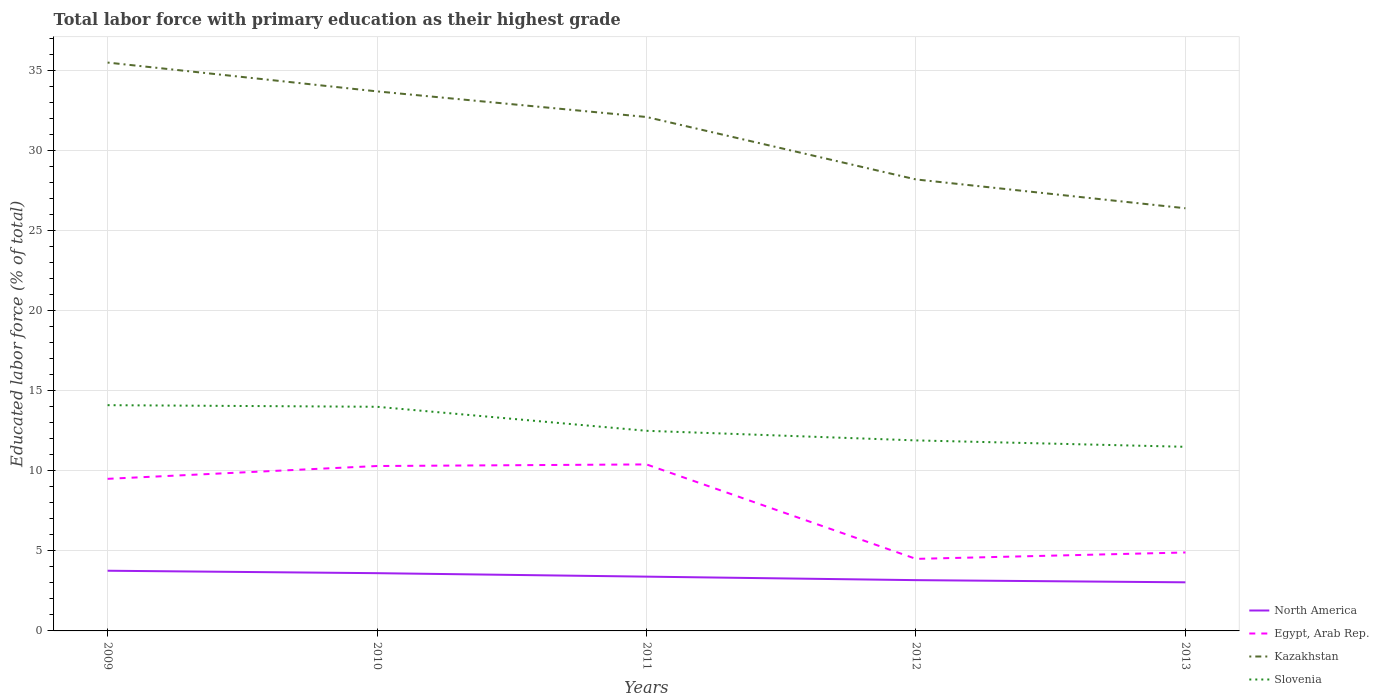How many different coloured lines are there?
Make the answer very short. 4. Does the line corresponding to North America intersect with the line corresponding to Slovenia?
Keep it short and to the point. No. Is the number of lines equal to the number of legend labels?
Keep it short and to the point. Yes. Across all years, what is the maximum percentage of total labor force with primary education in North America?
Your answer should be very brief. 3.04. In which year was the percentage of total labor force with primary education in North America maximum?
Give a very brief answer. 2013. What is the total percentage of total labor force with primary education in North America in the graph?
Offer a very short reply. 0.44. What is the difference between the highest and the second highest percentage of total labor force with primary education in Slovenia?
Provide a short and direct response. 2.6. What is the difference between the highest and the lowest percentage of total labor force with primary education in Slovenia?
Provide a succinct answer. 2. What is the difference between two consecutive major ticks on the Y-axis?
Ensure brevity in your answer.  5. Are the values on the major ticks of Y-axis written in scientific E-notation?
Keep it short and to the point. No. Does the graph contain any zero values?
Make the answer very short. No. Does the graph contain grids?
Your answer should be compact. Yes. What is the title of the graph?
Your answer should be very brief. Total labor force with primary education as their highest grade. Does "Bermuda" appear as one of the legend labels in the graph?
Your answer should be compact. No. What is the label or title of the X-axis?
Your response must be concise. Years. What is the label or title of the Y-axis?
Offer a terse response. Educated labor force (% of total). What is the Educated labor force (% of total) of North America in 2009?
Your answer should be very brief. 3.76. What is the Educated labor force (% of total) of Egypt, Arab Rep. in 2009?
Keep it short and to the point. 9.5. What is the Educated labor force (% of total) in Kazakhstan in 2009?
Ensure brevity in your answer.  35.5. What is the Educated labor force (% of total) in Slovenia in 2009?
Your answer should be compact. 14.1. What is the Educated labor force (% of total) of North America in 2010?
Make the answer very short. 3.61. What is the Educated labor force (% of total) in Egypt, Arab Rep. in 2010?
Keep it short and to the point. 10.3. What is the Educated labor force (% of total) of Kazakhstan in 2010?
Your response must be concise. 33.7. What is the Educated labor force (% of total) of North America in 2011?
Offer a terse response. 3.39. What is the Educated labor force (% of total) in Egypt, Arab Rep. in 2011?
Provide a succinct answer. 10.4. What is the Educated labor force (% of total) of Kazakhstan in 2011?
Offer a terse response. 32.1. What is the Educated labor force (% of total) in Slovenia in 2011?
Keep it short and to the point. 12.5. What is the Educated labor force (% of total) in North America in 2012?
Your answer should be very brief. 3.17. What is the Educated labor force (% of total) of Kazakhstan in 2012?
Provide a short and direct response. 28.2. What is the Educated labor force (% of total) of Slovenia in 2012?
Your answer should be compact. 11.9. What is the Educated labor force (% of total) in North America in 2013?
Offer a terse response. 3.04. What is the Educated labor force (% of total) of Egypt, Arab Rep. in 2013?
Your response must be concise. 4.9. What is the Educated labor force (% of total) in Kazakhstan in 2013?
Give a very brief answer. 26.4. What is the Educated labor force (% of total) of Slovenia in 2013?
Make the answer very short. 11.5. Across all years, what is the maximum Educated labor force (% of total) of North America?
Make the answer very short. 3.76. Across all years, what is the maximum Educated labor force (% of total) of Egypt, Arab Rep.?
Offer a very short reply. 10.4. Across all years, what is the maximum Educated labor force (% of total) of Kazakhstan?
Your response must be concise. 35.5. Across all years, what is the maximum Educated labor force (% of total) in Slovenia?
Your answer should be compact. 14.1. Across all years, what is the minimum Educated labor force (% of total) of North America?
Provide a short and direct response. 3.04. Across all years, what is the minimum Educated labor force (% of total) in Egypt, Arab Rep.?
Offer a terse response. 4.5. Across all years, what is the minimum Educated labor force (% of total) of Kazakhstan?
Offer a very short reply. 26.4. Across all years, what is the minimum Educated labor force (% of total) of Slovenia?
Your response must be concise. 11.5. What is the total Educated labor force (% of total) of North America in the graph?
Ensure brevity in your answer.  16.97. What is the total Educated labor force (% of total) in Egypt, Arab Rep. in the graph?
Ensure brevity in your answer.  39.6. What is the total Educated labor force (% of total) in Kazakhstan in the graph?
Your answer should be compact. 155.9. What is the difference between the Educated labor force (% of total) of North America in 2009 and that in 2010?
Make the answer very short. 0.15. What is the difference between the Educated labor force (% of total) in Kazakhstan in 2009 and that in 2010?
Provide a succinct answer. 1.8. What is the difference between the Educated labor force (% of total) in Slovenia in 2009 and that in 2010?
Offer a terse response. 0.1. What is the difference between the Educated labor force (% of total) in North America in 2009 and that in 2011?
Your response must be concise. 0.37. What is the difference between the Educated labor force (% of total) in Egypt, Arab Rep. in 2009 and that in 2011?
Offer a terse response. -0.9. What is the difference between the Educated labor force (% of total) of Slovenia in 2009 and that in 2011?
Provide a short and direct response. 1.6. What is the difference between the Educated labor force (% of total) of North America in 2009 and that in 2012?
Make the answer very short. 0.59. What is the difference between the Educated labor force (% of total) of North America in 2009 and that in 2013?
Your response must be concise. 0.72. What is the difference between the Educated labor force (% of total) of North America in 2010 and that in 2011?
Offer a terse response. 0.22. What is the difference between the Educated labor force (% of total) in Kazakhstan in 2010 and that in 2011?
Offer a terse response. 1.6. What is the difference between the Educated labor force (% of total) of North America in 2010 and that in 2012?
Your response must be concise. 0.44. What is the difference between the Educated labor force (% of total) of Egypt, Arab Rep. in 2010 and that in 2012?
Your response must be concise. 5.8. What is the difference between the Educated labor force (% of total) in Slovenia in 2010 and that in 2013?
Keep it short and to the point. 2.5. What is the difference between the Educated labor force (% of total) of North America in 2011 and that in 2012?
Ensure brevity in your answer.  0.22. What is the difference between the Educated labor force (% of total) of Egypt, Arab Rep. in 2011 and that in 2012?
Your answer should be compact. 5.9. What is the difference between the Educated labor force (% of total) of Slovenia in 2011 and that in 2012?
Provide a succinct answer. 0.6. What is the difference between the Educated labor force (% of total) of North America in 2011 and that in 2013?
Keep it short and to the point. 0.35. What is the difference between the Educated labor force (% of total) of Egypt, Arab Rep. in 2011 and that in 2013?
Your answer should be compact. 5.5. What is the difference between the Educated labor force (% of total) of Slovenia in 2011 and that in 2013?
Your answer should be compact. 1. What is the difference between the Educated labor force (% of total) in North America in 2012 and that in 2013?
Offer a very short reply. 0.14. What is the difference between the Educated labor force (% of total) in North America in 2009 and the Educated labor force (% of total) in Egypt, Arab Rep. in 2010?
Your answer should be compact. -6.54. What is the difference between the Educated labor force (% of total) in North America in 2009 and the Educated labor force (% of total) in Kazakhstan in 2010?
Ensure brevity in your answer.  -29.94. What is the difference between the Educated labor force (% of total) in North America in 2009 and the Educated labor force (% of total) in Slovenia in 2010?
Keep it short and to the point. -10.24. What is the difference between the Educated labor force (% of total) in Egypt, Arab Rep. in 2009 and the Educated labor force (% of total) in Kazakhstan in 2010?
Make the answer very short. -24.2. What is the difference between the Educated labor force (% of total) in Egypt, Arab Rep. in 2009 and the Educated labor force (% of total) in Slovenia in 2010?
Your answer should be very brief. -4.5. What is the difference between the Educated labor force (% of total) in North America in 2009 and the Educated labor force (% of total) in Egypt, Arab Rep. in 2011?
Offer a very short reply. -6.64. What is the difference between the Educated labor force (% of total) of North America in 2009 and the Educated labor force (% of total) of Kazakhstan in 2011?
Your answer should be very brief. -28.34. What is the difference between the Educated labor force (% of total) in North America in 2009 and the Educated labor force (% of total) in Slovenia in 2011?
Ensure brevity in your answer.  -8.74. What is the difference between the Educated labor force (% of total) of Egypt, Arab Rep. in 2009 and the Educated labor force (% of total) of Kazakhstan in 2011?
Your answer should be very brief. -22.6. What is the difference between the Educated labor force (% of total) in Kazakhstan in 2009 and the Educated labor force (% of total) in Slovenia in 2011?
Offer a terse response. 23. What is the difference between the Educated labor force (% of total) of North America in 2009 and the Educated labor force (% of total) of Egypt, Arab Rep. in 2012?
Your response must be concise. -0.74. What is the difference between the Educated labor force (% of total) of North America in 2009 and the Educated labor force (% of total) of Kazakhstan in 2012?
Offer a terse response. -24.44. What is the difference between the Educated labor force (% of total) of North America in 2009 and the Educated labor force (% of total) of Slovenia in 2012?
Give a very brief answer. -8.14. What is the difference between the Educated labor force (% of total) of Egypt, Arab Rep. in 2009 and the Educated labor force (% of total) of Kazakhstan in 2012?
Your answer should be very brief. -18.7. What is the difference between the Educated labor force (% of total) of Kazakhstan in 2009 and the Educated labor force (% of total) of Slovenia in 2012?
Make the answer very short. 23.6. What is the difference between the Educated labor force (% of total) of North America in 2009 and the Educated labor force (% of total) of Egypt, Arab Rep. in 2013?
Provide a short and direct response. -1.14. What is the difference between the Educated labor force (% of total) in North America in 2009 and the Educated labor force (% of total) in Kazakhstan in 2013?
Your response must be concise. -22.64. What is the difference between the Educated labor force (% of total) in North America in 2009 and the Educated labor force (% of total) in Slovenia in 2013?
Provide a short and direct response. -7.74. What is the difference between the Educated labor force (% of total) of Egypt, Arab Rep. in 2009 and the Educated labor force (% of total) of Kazakhstan in 2013?
Your answer should be very brief. -16.9. What is the difference between the Educated labor force (% of total) in Egypt, Arab Rep. in 2009 and the Educated labor force (% of total) in Slovenia in 2013?
Ensure brevity in your answer.  -2. What is the difference between the Educated labor force (% of total) in Kazakhstan in 2009 and the Educated labor force (% of total) in Slovenia in 2013?
Offer a terse response. 24. What is the difference between the Educated labor force (% of total) in North America in 2010 and the Educated labor force (% of total) in Egypt, Arab Rep. in 2011?
Keep it short and to the point. -6.79. What is the difference between the Educated labor force (% of total) in North America in 2010 and the Educated labor force (% of total) in Kazakhstan in 2011?
Give a very brief answer. -28.49. What is the difference between the Educated labor force (% of total) of North America in 2010 and the Educated labor force (% of total) of Slovenia in 2011?
Make the answer very short. -8.89. What is the difference between the Educated labor force (% of total) of Egypt, Arab Rep. in 2010 and the Educated labor force (% of total) of Kazakhstan in 2011?
Keep it short and to the point. -21.8. What is the difference between the Educated labor force (% of total) of Kazakhstan in 2010 and the Educated labor force (% of total) of Slovenia in 2011?
Ensure brevity in your answer.  21.2. What is the difference between the Educated labor force (% of total) of North America in 2010 and the Educated labor force (% of total) of Egypt, Arab Rep. in 2012?
Give a very brief answer. -0.89. What is the difference between the Educated labor force (% of total) of North America in 2010 and the Educated labor force (% of total) of Kazakhstan in 2012?
Your response must be concise. -24.59. What is the difference between the Educated labor force (% of total) in North America in 2010 and the Educated labor force (% of total) in Slovenia in 2012?
Your response must be concise. -8.29. What is the difference between the Educated labor force (% of total) of Egypt, Arab Rep. in 2010 and the Educated labor force (% of total) of Kazakhstan in 2012?
Offer a terse response. -17.9. What is the difference between the Educated labor force (% of total) in Egypt, Arab Rep. in 2010 and the Educated labor force (% of total) in Slovenia in 2012?
Provide a succinct answer. -1.6. What is the difference between the Educated labor force (% of total) in Kazakhstan in 2010 and the Educated labor force (% of total) in Slovenia in 2012?
Offer a terse response. 21.8. What is the difference between the Educated labor force (% of total) of North America in 2010 and the Educated labor force (% of total) of Egypt, Arab Rep. in 2013?
Make the answer very short. -1.29. What is the difference between the Educated labor force (% of total) in North America in 2010 and the Educated labor force (% of total) in Kazakhstan in 2013?
Your answer should be very brief. -22.79. What is the difference between the Educated labor force (% of total) in North America in 2010 and the Educated labor force (% of total) in Slovenia in 2013?
Your answer should be very brief. -7.89. What is the difference between the Educated labor force (% of total) in Egypt, Arab Rep. in 2010 and the Educated labor force (% of total) in Kazakhstan in 2013?
Provide a short and direct response. -16.1. What is the difference between the Educated labor force (% of total) of Egypt, Arab Rep. in 2010 and the Educated labor force (% of total) of Slovenia in 2013?
Make the answer very short. -1.2. What is the difference between the Educated labor force (% of total) of Kazakhstan in 2010 and the Educated labor force (% of total) of Slovenia in 2013?
Make the answer very short. 22.2. What is the difference between the Educated labor force (% of total) in North America in 2011 and the Educated labor force (% of total) in Egypt, Arab Rep. in 2012?
Offer a very short reply. -1.11. What is the difference between the Educated labor force (% of total) of North America in 2011 and the Educated labor force (% of total) of Kazakhstan in 2012?
Offer a very short reply. -24.81. What is the difference between the Educated labor force (% of total) of North America in 2011 and the Educated labor force (% of total) of Slovenia in 2012?
Your answer should be compact. -8.51. What is the difference between the Educated labor force (% of total) in Egypt, Arab Rep. in 2011 and the Educated labor force (% of total) in Kazakhstan in 2012?
Offer a very short reply. -17.8. What is the difference between the Educated labor force (% of total) in Kazakhstan in 2011 and the Educated labor force (% of total) in Slovenia in 2012?
Keep it short and to the point. 20.2. What is the difference between the Educated labor force (% of total) of North America in 2011 and the Educated labor force (% of total) of Egypt, Arab Rep. in 2013?
Make the answer very short. -1.51. What is the difference between the Educated labor force (% of total) in North America in 2011 and the Educated labor force (% of total) in Kazakhstan in 2013?
Offer a terse response. -23.01. What is the difference between the Educated labor force (% of total) in North America in 2011 and the Educated labor force (% of total) in Slovenia in 2013?
Your answer should be compact. -8.11. What is the difference between the Educated labor force (% of total) in Egypt, Arab Rep. in 2011 and the Educated labor force (% of total) in Kazakhstan in 2013?
Your answer should be very brief. -16. What is the difference between the Educated labor force (% of total) in Egypt, Arab Rep. in 2011 and the Educated labor force (% of total) in Slovenia in 2013?
Give a very brief answer. -1.1. What is the difference between the Educated labor force (% of total) in Kazakhstan in 2011 and the Educated labor force (% of total) in Slovenia in 2013?
Make the answer very short. 20.6. What is the difference between the Educated labor force (% of total) in North America in 2012 and the Educated labor force (% of total) in Egypt, Arab Rep. in 2013?
Provide a succinct answer. -1.73. What is the difference between the Educated labor force (% of total) in North America in 2012 and the Educated labor force (% of total) in Kazakhstan in 2013?
Give a very brief answer. -23.23. What is the difference between the Educated labor force (% of total) of North America in 2012 and the Educated labor force (% of total) of Slovenia in 2013?
Offer a terse response. -8.33. What is the difference between the Educated labor force (% of total) in Egypt, Arab Rep. in 2012 and the Educated labor force (% of total) in Kazakhstan in 2013?
Your answer should be compact. -21.9. What is the difference between the Educated labor force (% of total) of Egypt, Arab Rep. in 2012 and the Educated labor force (% of total) of Slovenia in 2013?
Offer a terse response. -7. What is the difference between the Educated labor force (% of total) of Kazakhstan in 2012 and the Educated labor force (% of total) of Slovenia in 2013?
Provide a succinct answer. 16.7. What is the average Educated labor force (% of total) of North America per year?
Provide a succinct answer. 3.39. What is the average Educated labor force (% of total) of Egypt, Arab Rep. per year?
Offer a very short reply. 7.92. What is the average Educated labor force (% of total) of Kazakhstan per year?
Offer a very short reply. 31.18. What is the average Educated labor force (% of total) in Slovenia per year?
Your answer should be compact. 12.8. In the year 2009, what is the difference between the Educated labor force (% of total) in North America and Educated labor force (% of total) in Egypt, Arab Rep.?
Ensure brevity in your answer.  -5.74. In the year 2009, what is the difference between the Educated labor force (% of total) of North America and Educated labor force (% of total) of Kazakhstan?
Offer a very short reply. -31.74. In the year 2009, what is the difference between the Educated labor force (% of total) in North America and Educated labor force (% of total) in Slovenia?
Your answer should be very brief. -10.34. In the year 2009, what is the difference between the Educated labor force (% of total) in Kazakhstan and Educated labor force (% of total) in Slovenia?
Ensure brevity in your answer.  21.4. In the year 2010, what is the difference between the Educated labor force (% of total) in North America and Educated labor force (% of total) in Egypt, Arab Rep.?
Provide a succinct answer. -6.69. In the year 2010, what is the difference between the Educated labor force (% of total) in North America and Educated labor force (% of total) in Kazakhstan?
Keep it short and to the point. -30.09. In the year 2010, what is the difference between the Educated labor force (% of total) in North America and Educated labor force (% of total) in Slovenia?
Your response must be concise. -10.39. In the year 2010, what is the difference between the Educated labor force (% of total) of Egypt, Arab Rep. and Educated labor force (% of total) of Kazakhstan?
Provide a short and direct response. -23.4. In the year 2010, what is the difference between the Educated labor force (% of total) in Egypt, Arab Rep. and Educated labor force (% of total) in Slovenia?
Your answer should be very brief. -3.7. In the year 2011, what is the difference between the Educated labor force (% of total) in North America and Educated labor force (% of total) in Egypt, Arab Rep.?
Make the answer very short. -7.01. In the year 2011, what is the difference between the Educated labor force (% of total) in North America and Educated labor force (% of total) in Kazakhstan?
Ensure brevity in your answer.  -28.71. In the year 2011, what is the difference between the Educated labor force (% of total) in North America and Educated labor force (% of total) in Slovenia?
Give a very brief answer. -9.11. In the year 2011, what is the difference between the Educated labor force (% of total) of Egypt, Arab Rep. and Educated labor force (% of total) of Kazakhstan?
Offer a very short reply. -21.7. In the year 2011, what is the difference between the Educated labor force (% of total) of Kazakhstan and Educated labor force (% of total) of Slovenia?
Offer a very short reply. 19.6. In the year 2012, what is the difference between the Educated labor force (% of total) in North America and Educated labor force (% of total) in Egypt, Arab Rep.?
Provide a short and direct response. -1.33. In the year 2012, what is the difference between the Educated labor force (% of total) in North America and Educated labor force (% of total) in Kazakhstan?
Your answer should be very brief. -25.03. In the year 2012, what is the difference between the Educated labor force (% of total) in North America and Educated labor force (% of total) in Slovenia?
Provide a succinct answer. -8.73. In the year 2012, what is the difference between the Educated labor force (% of total) of Egypt, Arab Rep. and Educated labor force (% of total) of Kazakhstan?
Your answer should be very brief. -23.7. In the year 2012, what is the difference between the Educated labor force (% of total) in Egypt, Arab Rep. and Educated labor force (% of total) in Slovenia?
Provide a succinct answer. -7.4. In the year 2013, what is the difference between the Educated labor force (% of total) of North America and Educated labor force (% of total) of Egypt, Arab Rep.?
Provide a short and direct response. -1.86. In the year 2013, what is the difference between the Educated labor force (% of total) in North America and Educated labor force (% of total) in Kazakhstan?
Your response must be concise. -23.36. In the year 2013, what is the difference between the Educated labor force (% of total) of North America and Educated labor force (% of total) of Slovenia?
Give a very brief answer. -8.46. In the year 2013, what is the difference between the Educated labor force (% of total) of Egypt, Arab Rep. and Educated labor force (% of total) of Kazakhstan?
Give a very brief answer. -21.5. What is the ratio of the Educated labor force (% of total) of North America in 2009 to that in 2010?
Offer a very short reply. 1.04. What is the ratio of the Educated labor force (% of total) in Egypt, Arab Rep. in 2009 to that in 2010?
Your response must be concise. 0.92. What is the ratio of the Educated labor force (% of total) in Kazakhstan in 2009 to that in 2010?
Provide a short and direct response. 1.05. What is the ratio of the Educated labor force (% of total) in Slovenia in 2009 to that in 2010?
Provide a short and direct response. 1.01. What is the ratio of the Educated labor force (% of total) of North America in 2009 to that in 2011?
Keep it short and to the point. 1.11. What is the ratio of the Educated labor force (% of total) of Egypt, Arab Rep. in 2009 to that in 2011?
Keep it short and to the point. 0.91. What is the ratio of the Educated labor force (% of total) of Kazakhstan in 2009 to that in 2011?
Ensure brevity in your answer.  1.11. What is the ratio of the Educated labor force (% of total) in Slovenia in 2009 to that in 2011?
Give a very brief answer. 1.13. What is the ratio of the Educated labor force (% of total) in North America in 2009 to that in 2012?
Your answer should be compact. 1.19. What is the ratio of the Educated labor force (% of total) in Egypt, Arab Rep. in 2009 to that in 2012?
Give a very brief answer. 2.11. What is the ratio of the Educated labor force (% of total) in Kazakhstan in 2009 to that in 2012?
Give a very brief answer. 1.26. What is the ratio of the Educated labor force (% of total) of Slovenia in 2009 to that in 2012?
Ensure brevity in your answer.  1.18. What is the ratio of the Educated labor force (% of total) in North America in 2009 to that in 2013?
Keep it short and to the point. 1.24. What is the ratio of the Educated labor force (% of total) of Egypt, Arab Rep. in 2009 to that in 2013?
Your response must be concise. 1.94. What is the ratio of the Educated labor force (% of total) of Kazakhstan in 2009 to that in 2013?
Give a very brief answer. 1.34. What is the ratio of the Educated labor force (% of total) of Slovenia in 2009 to that in 2013?
Provide a succinct answer. 1.23. What is the ratio of the Educated labor force (% of total) in North America in 2010 to that in 2011?
Your response must be concise. 1.06. What is the ratio of the Educated labor force (% of total) of Egypt, Arab Rep. in 2010 to that in 2011?
Your answer should be compact. 0.99. What is the ratio of the Educated labor force (% of total) in Kazakhstan in 2010 to that in 2011?
Make the answer very short. 1.05. What is the ratio of the Educated labor force (% of total) in Slovenia in 2010 to that in 2011?
Your answer should be compact. 1.12. What is the ratio of the Educated labor force (% of total) in North America in 2010 to that in 2012?
Your answer should be compact. 1.14. What is the ratio of the Educated labor force (% of total) of Egypt, Arab Rep. in 2010 to that in 2012?
Make the answer very short. 2.29. What is the ratio of the Educated labor force (% of total) in Kazakhstan in 2010 to that in 2012?
Ensure brevity in your answer.  1.2. What is the ratio of the Educated labor force (% of total) in Slovenia in 2010 to that in 2012?
Your answer should be very brief. 1.18. What is the ratio of the Educated labor force (% of total) in North America in 2010 to that in 2013?
Offer a very short reply. 1.19. What is the ratio of the Educated labor force (% of total) in Egypt, Arab Rep. in 2010 to that in 2013?
Provide a succinct answer. 2.1. What is the ratio of the Educated labor force (% of total) of Kazakhstan in 2010 to that in 2013?
Offer a very short reply. 1.28. What is the ratio of the Educated labor force (% of total) in Slovenia in 2010 to that in 2013?
Your answer should be very brief. 1.22. What is the ratio of the Educated labor force (% of total) of North America in 2011 to that in 2012?
Keep it short and to the point. 1.07. What is the ratio of the Educated labor force (% of total) of Egypt, Arab Rep. in 2011 to that in 2012?
Give a very brief answer. 2.31. What is the ratio of the Educated labor force (% of total) in Kazakhstan in 2011 to that in 2012?
Keep it short and to the point. 1.14. What is the ratio of the Educated labor force (% of total) in Slovenia in 2011 to that in 2012?
Your response must be concise. 1.05. What is the ratio of the Educated labor force (% of total) in North America in 2011 to that in 2013?
Give a very brief answer. 1.12. What is the ratio of the Educated labor force (% of total) of Egypt, Arab Rep. in 2011 to that in 2013?
Your response must be concise. 2.12. What is the ratio of the Educated labor force (% of total) of Kazakhstan in 2011 to that in 2013?
Provide a short and direct response. 1.22. What is the ratio of the Educated labor force (% of total) of Slovenia in 2011 to that in 2013?
Give a very brief answer. 1.09. What is the ratio of the Educated labor force (% of total) of North America in 2012 to that in 2013?
Give a very brief answer. 1.04. What is the ratio of the Educated labor force (% of total) in Egypt, Arab Rep. in 2012 to that in 2013?
Provide a short and direct response. 0.92. What is the ratio of the Educated labor force (% of total) of Kazakhstan in 2012 to that in 2013?
Your response must be concise. 1.07. What is the ratio of the Educated labor force (% of total) in Slovenia in 2012 to that in 2013?
Offer a very short reply. 1.03. What is the difference between the highest and the second highest Educated labor force (% of total) of North America?
Provide a succinct answer. 0.15. What is the difference between the highest and the second highest Educated labor force (% of total) in Egypt, Arab Rep.?
Provide a succinct answer. 0.1. What is the difference between the highest and the lowest Educated labor force (% of total) in North America?
Your answer should be very brief. 0.72. What is the difference between the highest and the lowest Educated labor force (% of total) in Egypt, Arab Rep.?
Your response must be concise. 5.9. What is the difference between the highest and the lowest Educated labor force (% of total) in Slovenia?
Offer a terse response. 2.6. 